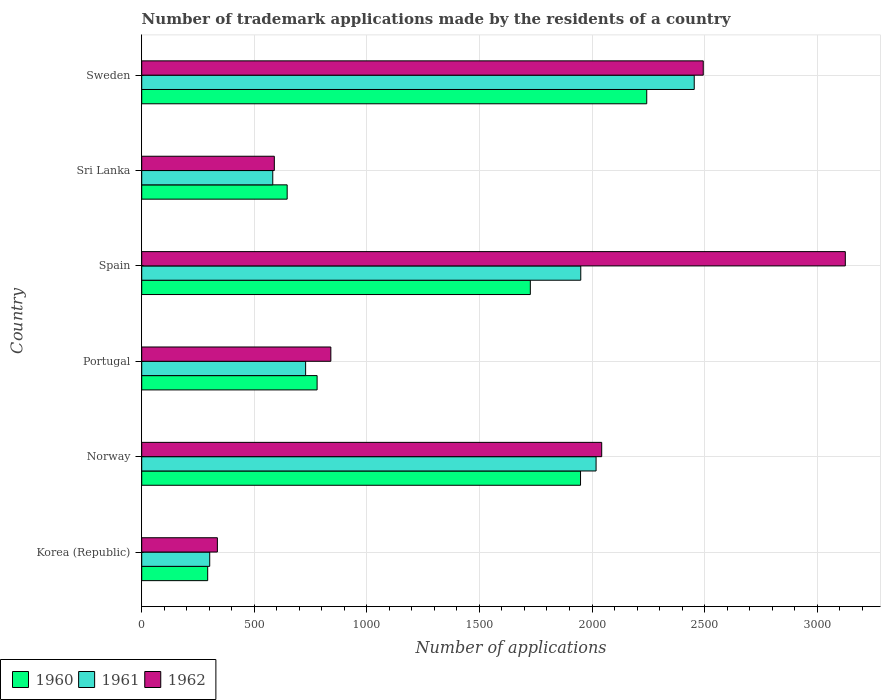How many bars are there on the 6th tick from the top?
Make the answer very short. 3. What is the number of trademark applications made by the residents in 1962 in Portugal?
Provide a short and direct response. 840. Across all countries, what is the maximum number of trademark applications made by the residents in 1960?
Your answer should be very brief. 2243. Across all countries, what is the minimum number of trademark applications made by the residents in 1961?
Offer a terse response. 302. In which country was the number of trademark applications made by the residents in 1961 minimum?
Give a very brief answer. Korea (Republic). What is the total number of trademark applications made by the residents in 1962 in the graph?
Offer a terse response. 9427. What is the difference between the number of trademark applications made by the residents in 1960 in Sri Lanka and that in Sweden?
Give a very brief answer. -1597. What is the difference between the number of trademark applications made by the residents in 1961 in Sri Lanka and the number of trademark applications made by the residents in 1960 in Spain?
Provide a succinct answer. -1144. What is the average number of trademark applications made by the residents in 1960 per country?
Make the answer very short. 1272.67. What is the ratio of the number of trademark applications made by the residents in 1960 in Norway to that in Sweden?
Provide a short and direct response. 0.87. Is the difference between the number of trademark applications made by the residents in 1962 in Spain and Sweden greater than the difference between the number of trademark applications made by the residents in 1960 in Spain and Sweden?
Your response must be concise. Yes. What is the difference between the highest and the second highest number of trademark applications made by the residents in 1961?
Keep it short and to the point. 436. What is the difference between the highest and the lowest number of trademark applications made by the residents in 1960?
Your answer should be compact. 1950. In how many countries, is the number of trademark applications made by the residents in 1960 greater than the average number of trademark applications made by the residents in 1960 taken over all countries?
Offer a very short reply. 3. Is the sum of the number of trademark applications made by the residents in 1962 in Korea (Republic) and Sri Lanka greater than the maximum number of trademark applications made by the residents in 1960 across all countries?
Ensure brevity in your answer.  No. What does the 1st bar from the top in Korea (Republic) represents?
Your answer should be compact. 1962. What does the 3rd bar from the bottom in Spain represents?
Provide a succinct answer. 1962. Is it the case that in every country, the sum of the number of trademark applications made by the residents in 1962 and number of trademark applications made by the residents in 1961 is greater than the number of trademark applications made by the residents in 1960?
Your answer should be very brief. Yes. How many countries are there in the graph?
Offer a very short reply. 6. Are the values on the major ticks of X-axis written in scientific E-notation?
Ensure brevity in your answer.  No. Where does the legend appear in the graph?
Give a very brief answer. Bottom left. How are the legend labels stacked?
Give a very brief answer. Horizontal. What is the title of the graph?
Ensure brevity in your answer.  Number of trademark applications made by the residents of a country. What is the label or title of the X-axis?
Give a very brief answer. Number of applications. What is the Number of applications of 1960 in Korea (Republic)?
Give a very brief answer. 293. What is the Number of applications in 1961 in Korea (Republic)?
Provide a short and direct response. 302. What is the Number of applications in 1962 in Korea (Republic)?
Keep it short and to the point. 336. What is the Number of applications in 1960 in Norway?
Your answer should be very brief. 1949. What is the Number of applications of 1961 in Norway?
Your response must be concise. 2018. What is the Number of applications of 1962 in Norway?
Offer a very short reply. 2043. What is the Number of applications of 1960 in Portugal?
Keep it short and to the point. 779. What is the Number of applications in 1961 in Portugal?
Your answer should be very brief. 728. What is the Number of applications in 1962 in Portugal?
Make the answer very short. 840. What is the Number of applications in 1960 in Spain?
Your answer should be very brief. 1726. What is the Number of applications in 1961 in Spain?
Your answer should be compact. 1950. What is the Number of applications in 1962 in Spain?
Your answer should be compact. 3125. What is the Number of applications of 1960 in Sri Lanka?
Provide a succinct answer. 646. What is the Number of applications of 1961 in Sri Lanka?
Give a very brief answer. 582. What is the Number of applications of 1962 in Sri Lanka?
Ensure brevity in your answer.  589. What is the Number of applications of 1960 in Sweden?
Provide a succinct answer. 2243. What is the Number of applications in 1961 in Sweden?
Offer a very short reply. 2454. What is the Number of applications of 1962 in Sweden?
Provide a short and direct response. 2494. Across all countries, what is the maximum Number of applications in 1960?
Provide a succinct answer. 2243. Across all countries, what is the maximum Number of applications of 1961?
Offer a very short reply. 2454. Across all countries, what is the maximum Number of applications in 1962?
Give a very brief answer. 3125. Across all countries, what is the minimum Number of applications of 1960?
Your answer should be compact. 293. Across all countries, what is the minimum Number of applications in 1961?
Your answer should be compact. 302. Across all countries, what is the minimum Number of applications of 1962?
Ensure brevity in your answer.  336. What is the total Number of applications of 1960 in the graph?
Provide a short and direct response. 7636. What is the total Number of applications in 1961 in the graph?
Ensure brevity in your answer.  8034. What is the total Number of applications of 1962 in the graph?
Your answer should be compact. 9427. What is the difference between the Number of applications in 1960 in Korea (Republic) and that in Norway?
Your answer should be very brief. -1656. What is the difference between the Number of applications of 1961 in Korea (Republic) and that in Norway?
Your answer should be compact. -1716. What is the difference between the Number of applications in 1962 in Korea (Republic) and that in Norway?
Ensure brevity in your answer.  -1707. What is the difference between the Number of applications of 1960 in Korea (Republic) and that in Portugal?
Your answer should be very brief. -486. What is the difference between the Number of applications in 1961 in Korea (Republic) and that in Portugal?
Your answer should be compact. -426. What is the difference between the Number of applications in 1962 in Korea (Republic) and that in Portugal?
Offer a terse response. -504. What is the difference between the Number of applications of 1960 in Korea (Republic) and that in Spain?
Offer a terse response. -1433. What is the difference between the Number of applications of 1961 in Korea (Republic) and that in Spain?
Make the answer very short. -1648. What is the difference between the Number of applications of 1962 in Korea (Republic) and that in Spain?
Offer a very short reply. -2789. What is the difference between the Number of applications of 1960 in Korea (Republic) and that in Sri Lanka?
Provide a succinct answer. -353. What is the difference between the Number of applications in 1961 in Korea (Republic) and that in Sri Lanka?
Make the answer very short. -280. What is the difference between the Number of applications in 1962 in Korea (Republic) and that in Sri Lanka?
Offer a very short reply. -253. What is the difference between the Number of applications of 1960 in Korea (Republic) and that in Sweden?
Your response must be concise. -1950. What is the difference between the Number of applications of 1961 in Korea (Republic) and that in Sweden?
Your response must be concise. -2152. What is the difference between the Number of applications of 1962 in Korea (Republic) and that in Sweden?
Your response must be concise. -2158. What is the difference between the Number of applications of 1960 in Norway and that in Portugal?
Give a very brief answer. 1170. What is the difference between the Number of applications of 1961 in Norway and that in Portugal?
Keep it short and to the point. 1290. What is the difference between the Number of applications in 1962 in Norway and that in Portugal?
Offer a very short reply. 1203. What is the difference between the Number of applications in 1960 in Norway and that in Spain?
Ensure brevity in your answer.  223. What is the difference between the Number of applications of 1961 in Norway and that in Spain?
Give a very brief answer. 68. What is the difference between the Number of applications in 1962 in Norway and that in Spain?
Offer a very short reply. -1082. What is the difference between the Number of applications of 1960 in Norway and that in Sri Lanka?
Give a very brief answer. 1303. What is the difference between the Number of applications of 1961 in Norway and that in Sri Lanka?
Offer a very short reply. 1436. What is the difference between the Number of applications of 1962 in Norway and that in Sri Lanka?
Offer a terse response. 1454. What is the difference between the Number of applications in 1960 in Norway and that in Sweden?
Make the answer very short. -294. What is the difference between the Number of applications in 1961 in Norway and that in Sweden?
Offer a terse response. -436. What is the difference between the Number of applications in 1962 in Norway and that in Sweden?
Make the answer very short. -451. What is the difference between the Number of applications of 1960 in Portugal and that in Spain?
Offer a very short reply. -947. What is the difference between the Number of applications in 1961 in Portugal and that in Spain?
Make the answer very short. -1222. What is the difference between the Number of applications of 1962 in Portugal and that in Spain?
Give a very brief answer. -2285. What is the difference between the Number of applications of 1960 in Portugal and that in Sri Lanka?
Offer a terse response. 133. What is the difference between the Number of applications in 1961 in Portugal and that in Sri Lanka?
Your answer should be compact. 146. What is the difference between the Number of applications of 1962 in Portugal and that in Sri Lanka?
Give a very brief answer. 251. What is the difference between the Number of applications in 1960 in Portugal and that in Sweden?
Provide a succinct answer. -1464. What is the difference between the Number of applications of 1961 in Portugal and that in Sweden?
Provide a succinct answer. -1726. What is the difference between the Number of applications of 1962 in Portugal and that in Sweden?
Make the answer very short. -1654. What is the difference between the Number of applications of 1960 in Spain and that in Sri Lanka?
Offer a terse response. 1080. What is the difference between the Number of applications of 1961 in Spain and that in Sri Lanka?
Offer a very short reply. 1368. What is the difference between the Number of applications in 1962 in Spain and that in Sri Lanka?
Your answer should be very brief. 2536. What is the difference between the Number of applications in 1960 in Spain and that in Sweden?
Your answer should be compact. -517. What is the difference between the Number of applications in 1961 in Spain and that in Sweden?
Provide a short and direct response. -504. What is the difference between the Number of applications of 1962 in Spain and that in Sweden?
Keep it short and to the point. 631. What is the difference between the Number of applications of 1960 in Sri Lanka and that in Sweden?
Make the answer very short. -1597. What is the difference between the Number of applications of 1961 in Sri Lanka and that in Sweden?
Offer a very short reply. -1872. What is the difference between the Number of applications of 1962 in Sri Lanka and that in Sweden?
Offer a terse response. -1905. What is the difference between the Number of applications in 1960 in Korea (Republic) and the Number of applications in 1961 in Norway?
Provide a succinct answer. -1725. What is the difference between the Number of applications of 1960 in Korea (Republic) and the Number of applications of 1962 in Norway?
Provide a short and direct response. -1750. What is the difference between the Number of applications of 1961 in Korea (Republic) and the Number of applications of 1962 in Norway?
Your answer should be compact. -1741. What is the difference between the Number of applications in 1960 in Korea (Republic) and the Number of applications in 1961 in Portugal?
Make the answer very short. -435. What is the difference between the Number of applications in 1960 in Korea (Republic) and the Number of applications in 1962 in Portugal?
Give a very brief answer. -547. What is the difference between the Number of applications of 1961 in Korea (Republic) and the Number of applications of 1962 in Portugal?
Provide a succinct answer. -538. What is the difference between the Number of applications in 1960 in Korea (Republic) and the Number of applications in 1961 in Spain?
Your response must be concise. -1657. What is the difference between the Number of applications in 1960 in Korea (Republic) and the Number of applications in 1962 in Spain?
Keep it short and to the point. -2832. What is the difference between the Number of applications of 1961 in Korea (Republic) and the Number of applications of 1962 in Spain?
Provide a short and direct response. -2823. What is the difference between the Number of applications in 1960 in Korea (Republic) and the Number of applications in 1961 in Sri Lanka?
Give a very brief answer. -289. What is the difference between the Number of applications of 1960 in Korea (Republic) and the Number of applications of 1962 in Sri Lanka?
Provide a short and direct response. -296. What is the difference between the Number of applications of 1961 in Korea (Republic) and the Number of applications of 1962 in Sri Lanka?
Your answer should be compact. -287. What is the difference between the Number of applications of 1960 in Korea (Republic) and the Number of applications of 1961 in Sweden?
Provide a short and direct response. -2161. What is the difference between the Number of applications of 1960 in Korea (Republic) and the Number of applications of 1962 in Sweden?
Your response must be concise. -2201. What is the difference between the Number of applications of 1961 in Korea (Republic) and the Number of applications of 1962 in Sweden?
Your response must be concise. -2192. What is the difference between the Number of applications of 1960 in Norway and the Number of applications of 1961 in Portugal?
Ensure brevity in your answer.  1221. What is the difference between the Number of applications of 1960 in Norway and the Number of applications of 1962 in Portugal?
Keep it short and to the point. 1109. What is the difference between the Number of applications in 1961 in Norway and the Number of applications in 1962 in Portugal?
Your answer should be compact. 1178. What is the difference between the Number of applications of 1960 in Norway and the Number of applications of 1962 in Spain?
Ensure brevity in your answer.  -1176. What is the difference between the Number of applications in 1961 in Norway and the Number of applications in 1962 in Spain?
Offer a very short reply. -1107. What is the difference between the Number of applications in 1960 in Norway and the Number of applications in 1961 in Sri Lanka?
Offer a very short reply. 1367. What is the difference between the Number of applications in 1960 in Norway and the Number of applications in 1962 in Sri Lanka?
Your response must be concise. 1360. What is the difference between the Number of applications of 1961 in Norway and the Number of applications of 1962 in Sri Lanka?
Offer a very short reply. 1429. What is the difference between the Number of applications in 1960 in Norway and the Number of applications in 1961 in Sweden?
Make the answer very short. -505. What is the difference between the Number of applications of 1960 in Norway and the Number of applications of 1962 in Sweden?
Offer a terse response. -545. What is the difference between the Number of applications in 1961 in Norway and the Number of applications in 1962 in Sweden?
Your answer should be compact. -476. What is the difference between the Number of applications of 1960 in Portugal and the Number of applications of 1961 in Spain?
Offer a terse response. -1171. What is the difference between the Number of applications of 1960 in Portugal and the Number of applications of 1962 in Spain?
Provide a short and direct response. -2346. What is the difference between the Number of applications in 1961 in Portugal and the Number of applications in 1962 in Spain?
Give a very brief answer. -2397. What is the difference between the Number of applications of 1960 in Portugal and the Number of applications of 1961 in Sri Lanka?
Give a very brief answer. 197. What is the difference between the Number of applications in 1960 in Portugal and the Number of applications in 1962 in Sri Lanka?
Your answer should be very brief. 190. What is the difference between the Number of applications in 1961 in Portugal and the Number of applications in 1962 in Sri Lanka?
Ensure brevity in your answer.  139. What is the difference between the Number of applications in 1960 in Portugal and the Number of applications in 1961 in Sweden?
Your response must be concise. -1675. What is the difference between the Number of applications of 1960 in Portugal and the Number of applications of 1962 in Sweden?
Your answer should be compact. -1715. What is the difference between the Number of applications in 1961 in Portugal and the Number of applications in 1962 in Sweden?
Your answer should be very brief. -1766. What is the difference between the Number of applications in 1960 in Spain and the Number of applications in 1961 in Sri Lanka?
Your response must be concise. 1144. What is the difference between the Number of applications in 1960 in Spain and the Number of applications in 1962 in Sri Lanka?
Your answer should be compact. 1137. What is the difference between the Number of applications in 1961 in Spain and the Number of applications in 1962 in Sri Lanka?
Provide a short and direct response. 1361. What is the difference between the Number of applications of 1960 in Spain and the Number of applications of 1961 in Sweden?
Provide a succinct answer. -728. What is the difference between the Number of applications in 1960 in Spain and the Number of applications in 1962 in Sweden?
Make the answer very short. -768. What is the difference between the Number of applications in 1961 in Spain and the Number of applications in 1962 in Sweden?
Ensure brevity in your answer.  -544. What is the difference between the Number of applications of 1960 in Sri Lanka and the Number of applications of 1961 in Sweden?
Your answer should be very brief. -1808. What is the difference between the Number of applications of 1960 in Sri Lanka and the Number of applications of 1962 in Sweden?
Provide a succinct answer. -1848. What is the difference between the Number of applications of 1961 in Sri Lanka and the Number of applications of 1962 in Sweden?
Your answer should be compact. -1912. What is the average Number of applications of 1960 per country?
Your response must be concise. 1272.67. What is the average Number of applications in 1961 per country?
Make the answer very short. 1339. What is the average Number of applications of 1962 per country?
Your answer should be very brief. 1571.17. What is the difference between the Number of applications of 1960 and Number of applications of 1961 in Korea (Republic)?
Provide a succinct answer. -9. What is the difference between the Number of applications of 1960 and Number of applications of 1962 in Korea (Republic)?
Your answer should be very brief. -43. What is the difference between the Number of applications in 1961 and Number of applications in 1962 in Korea (Republic)?
Your response must be concise. -34. What is the difference between the Number of applications of 1960 and Number of applications of 1961 in Norway?
Make the answer very short. -69. What is the difference between the Number of applications of 1960 and Number of applications of 1962 in Norway?
Provide a short and direct response. -94. What is the difference between the Number of applications of 1960 and Number of applications of 1961 in Portugal?
Make the answer very short. 51. What is the difference between the Number of applications in 1960 and Number of applications in 1962 in Portugal?
Give a very brief answer. -61. What is the difference between the Number of applications of 1961 and Number of applications of 1962 in Portugal?
Keep it short and to the point. -112. What is the difference between the Number of applications in 1960 and Number of applications in 1961 in Spain?
Provide a succinct answer. -224. What is the difference between the Number of applications in 1960 and Number of applications in 1962 in Spain?
Your response must be concise. -1399. What is the difference between the Number of applications of 1961 and Number of applications of 1962 in Spain?
Offer a terse response. -1175. What is the difference between the Number of applications of 1960 and Number of applications of 1962 in Sri Lanka?
Provide a short and direct response. 57. What is the difference between the Number of applications in 1960 and Number of applications in 1961 in Sweden?
Ensure brevity in your answer.  -211. What is the difference between the Number of applications in 1960 and Number of applications in 1962 in Sweden?
Offer a very short reply. -251. What is the ratio of the Number of applications in 1960 in Korea (Republic) to that in Norway?
Provide a short and direct response. 0.15. What is the ratio of the Number of applications in 1961 in Korea (Republic) to that in Norway?
Keep it short and to the point. 0.15. What is the ratio of the Number of applications of 1962 in Korea (Republic) to that in Norway?
Ensure brevity in your answer.  0.16. What is the ratio of the Number of applications of 1960 in Korea (Republic) to that in Portugal?
Keep it short and to the point. 0.38. What is the ratio of the Number of applications in 1961 in Korea (Republic) to that in Portugal?
Provide a succinct answer. 0.41. What is the ratio of the Number of applications in 1960 in Korea (Republic) to that in Spain?
Offer a terse response. 0.17. What is the ratio of the Number of applications of 1961 in Korea (Republic) to that in Spain?
Your answer should be compact. 0.15. What is the ratio of the Number of applications in 1962 in Korea (Republic) to that in Spain?
Ensure brevity in your answer.  0.11. What is the ratio of the Number of applications of 1960 in Korea (Republic) to that in Sri Lanka?
Your response must be concise. 0.45. What is the ratio of the Number of applications of 1961 in Korea (Republic) to that in Sri Lanka?
Offer a very short reply. 0.52. What is the ratio of the Number of applications in 1962 in Korea (Republic) to that in Sri Lanka?
Provide a short and direct response. 0.57. What is the ratio of the Number of applications of 1960 in Korea (Republic) to that in Sweden?
Offer a very short reply. 0.13. What is the ratio of the Number of applications in 1961 in Korea (Republic) to that in Sweden?
Your response must be concise. 0.12. What is the ratio of the Number of applications in 1962 in Korea (Republic) to that in Sweden?
Offer a terse response. 0.13. What is the ratio of the Number of applications of 1960 in Norway to that in Portugal?
Keep it short and to the point. 2.5. What is the ratio of the Number of applications of 1961 in Norway to that in Portugal?
Ensure brevity in your answer.  2.77. What is the ratio of the Number of applications of 1962 in Norway to that in Portugal?
Ensure brevity in your answer.  2.43. What is the ratio of the Number of applications of 1960 in Norway to that in Spain?
Give a very brief answer. 1.13. What is the ratio of the Number of applications of 1961 in Norway to that in Spain?
Your response must be concise. 1.03. What is the ratio of the Number of applications in 1962 in Norway to that in Spain?
Your answer should be compact. 0.65. What is the ratio of the Number of applications in 1960 in Norway to that in Sri Lanka?
Your response must be concise. 3.02. What is the ratio of the Number of applications of 1961 in Norway to that in Sri Lanka?
Offer a very short reply. 3.47. What is the ratio of the Number of applications of 1962 in Norway to that in Sri Lanka?
Your answer should be very brief. 3.47. What is the ratio of the Number of applications in 1960 in Norway to that in Sweden?
Provide a succinct answer. 0.87. What is the ratio of the Number of applications in 1961 in Norway to that in Sweden?
Provide a succinct answer. 0.82. What is the ratio of the Number of applications of 1962 in Norway to that in Sweden?
Offer a very short reply. 0.82. What is the ratio of the Number of applications of 1960 in Portugal to that in Spain?
Provide a short and direct response. 0.45. What is the ratio of the Number of applications of 1961 in Portugal to that in Spain?
Provide a short and direct response. 0.37. What is the ratio of the Number of applications of 1962 in Portugal to that in Spain?
Provide a short and direct response. 0.27. What is the ratio of the Number of applications in 1960 in Portugal to that in Sri Lanka?
Keep it short and to the point. 1.21. What is the ratio of the Number of applications of 1961 in Portugal to that in Sri Lanka?
Your answer should be very brief. 1.25. What is the ratio of the Number of applications of 1962 in Portugal to that in Sri Lanka?
Make the answer very short. 1.43. What is the ratio of the Number of applications of 1960 in Portugal to that in Sweden?
Keep it short and to the point. 0.35. What is the ratio of the Number of applications of 1961 in Portugal to that in Sweden?
Provide a succinct answer. 0.3. What is the ratio of the Number of applications in 1962 in Portugal to that in Sweden?
Provide a short and direct response. 0.34. What is the ratio of the Number of applications in 1960 in Spain to that in Sri Lanka?
Offer a very short reply. 2.67. What is the ratio of the Number of applications in 1961 in Spain to that in Sri Lanka?
Your answer should be very brief. 3.35. What is the ratio of the Number of applications in 1962 in Spain to that in Sri Lanka?
Give a very brief answer. 5.31. What is the ratio of the Number of applications in 1960 in Spain to that in Sweden?
Your answer should be compact. 0.77. What is the ratio of the Number of applications of 1961 in Spain to that in Sweden?
Keep it short and to the point. 0.79. What is the ratio of the Number of applications in 1962 in Spain to that in Sweden?
Ensure brevity in your answer.  1.25. What is the ratio of the Number of applications of 1960 in Sri Lanka to that in Sweden?
Give a very brief answer. 0.29. What is the ratio of the Number of applications of 1961 in Sri Lanka to that in Sweden?
Keep it short and to the point. 0.24. What is the ratio of the Number of applications in 1962 in Sri Lanka to that in Sweden?
Your response must be concise. 0.24. What is the difference between the highest and the second highest Number of applications in 1960?
Provide a succinct answer. 294. What is the difference between the highest and the second highest Number of applications of 1961?
Your response must be concise. 436. What is the difference between the highest and the second highest Number of applications in 1962?
Your answer should be compact. 631. What is the difference between the highest and the lowest Number of applications of 1960?
Provide a short and direct response. 1950. What is the difference between the highest and the lowest Number of applications of 1961?
Your answer should be very brief. 2152. What is the difference between the highest and the lowest Number of applications in 1962?
Make the answer very short. 2789. 